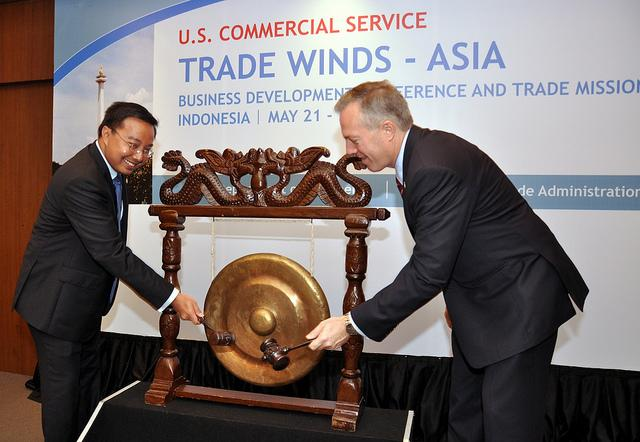What does hitting the gong here signal?

Choices:
A) opening
B) divorce
C) parity
D) grievance opening 